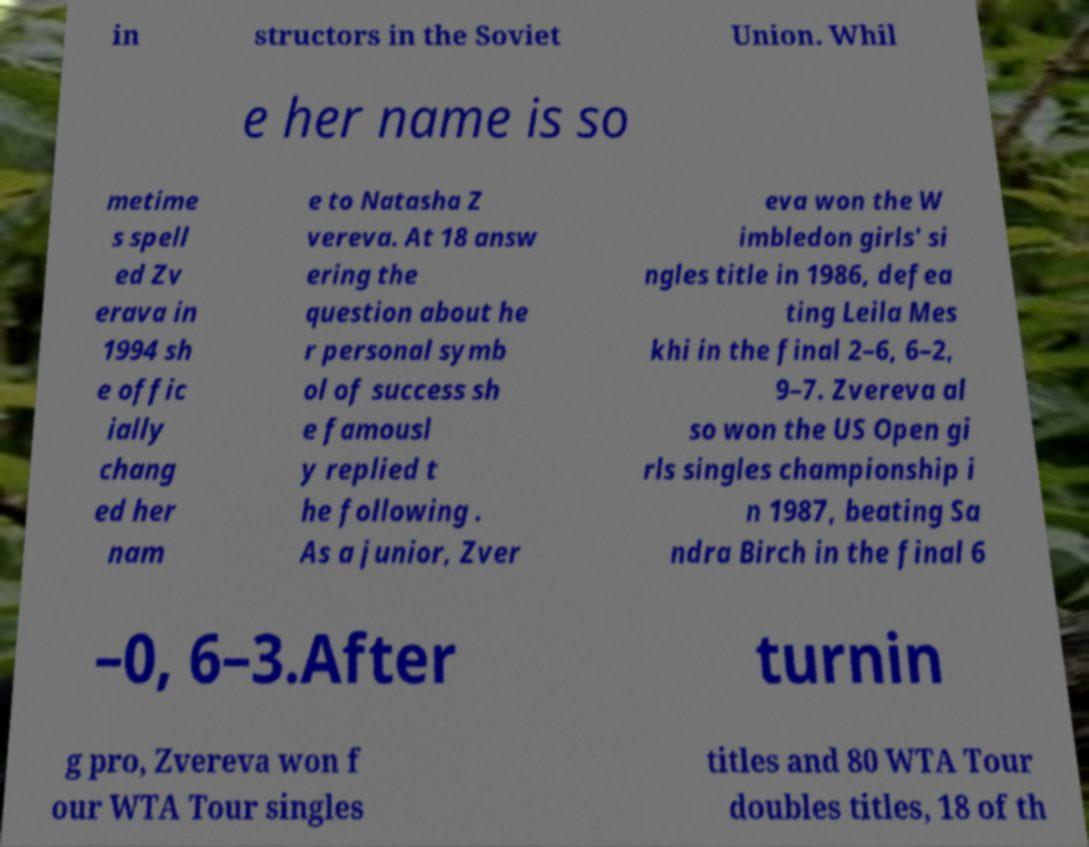I need the written content from this picture converted into text. Can you do that? in structors in the Soviet Union. Whil e her name is so metime s spell ed Zv erava in 1994 sh e offic ially chang ed her nam e to Natasha Z vereva. At 18 answ ering the question about he r personal symb ol of success sh e famousl y replied t he following . As a junior, Zver eva won the W imbledon girls' si ngles title in 1986, defea ting Leila Mes khi in the final 2–6, 6–2, 9–7. Zvereva al so won the US Open gi rls singles championship i n 1987, beating Sa ndra Birch in the final 6 –0, 6–3.After turnin g pro, Zvereva won f our WTA Tour singles titles and 80 WTA Tour doubles titles, 18 of th 